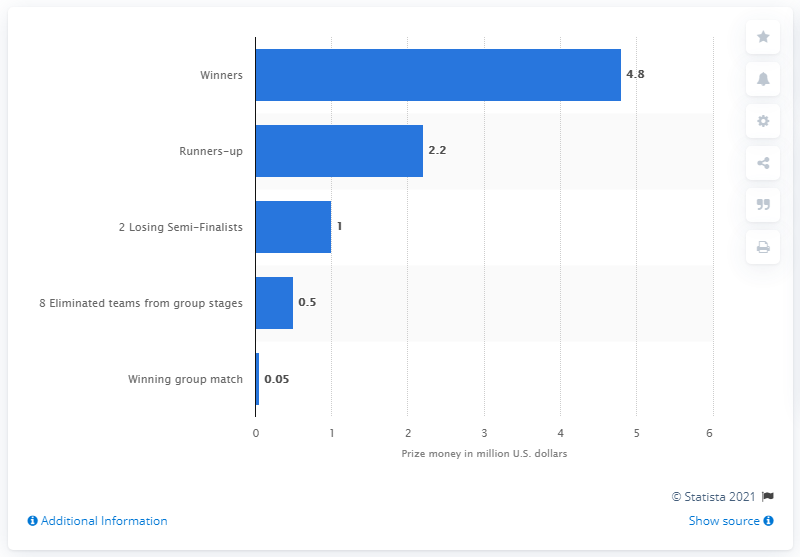Indicate a few pertinent items in this graphic. The winning team of the 2019 Cricket World Cup is set to receive a prize money of 4.8 billion dollars. 